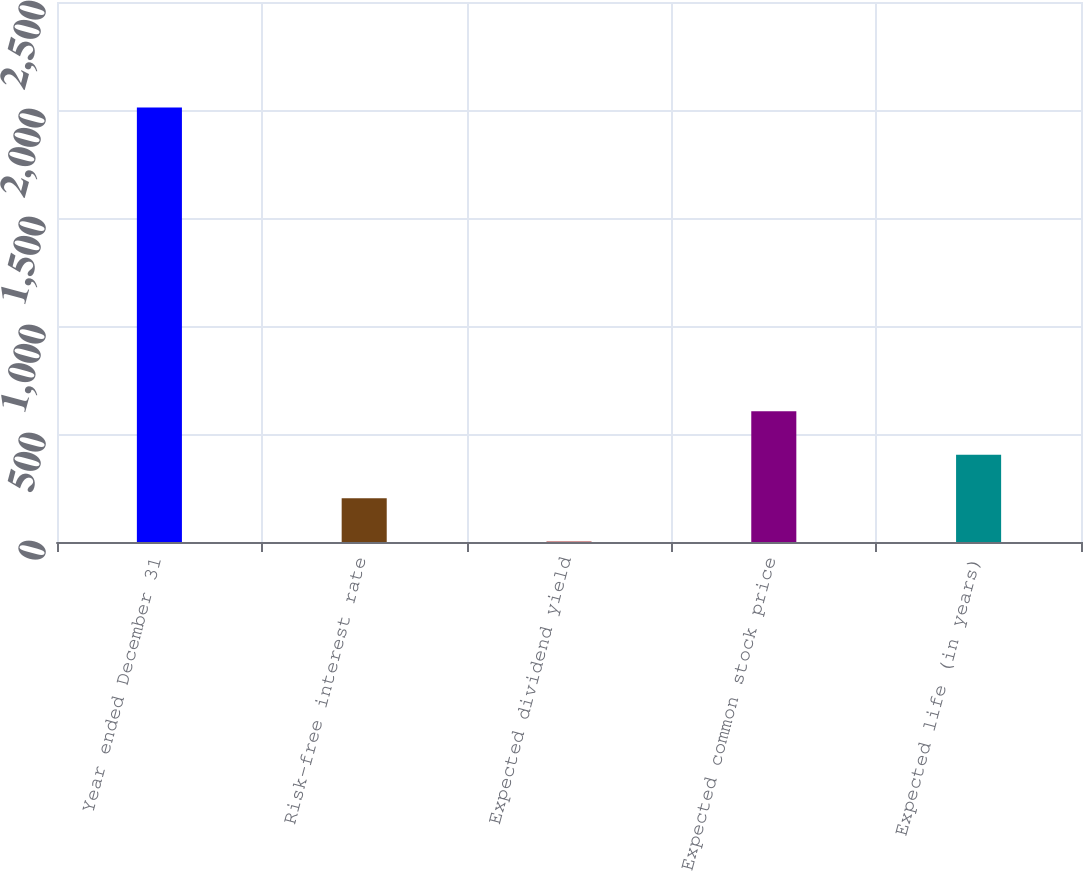Convert chart to OTSL. <chart><loc_0><loc_0><loc_500><loc_500><bar_chart><fcel>Year ended December 31<fcel>Risk-free interest rate<fcel>Expected dividend yield<fcel>Expected common stock price<fcel>Expected life (in years)<nl><fcel>2011<fcel>203.08<fcel>2.2<fcel>604.84<fcel>403.96<nl></chart> 